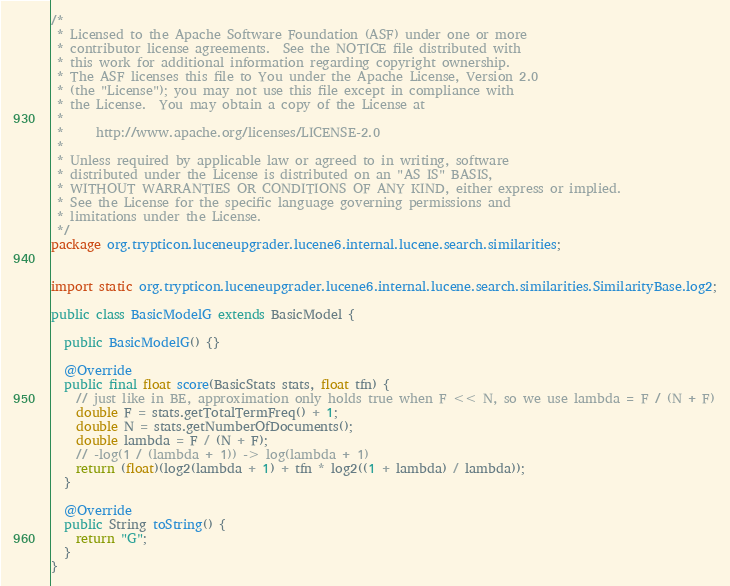<code> <loc_0><loc_0><loc_500><loc_500><_Java_>/*
 * Licensed to the Apache Software Foundation (ASF) under one or more
 * contributor license agreements.  See the NOTICE file distributed with
 * this work for additional information regarding copyright ownership.
 * The ASF licenses this file to You under the Apache License, Version 2.0
 * (the "License"); you may not use this file except in compliance with
 * the License.  You may obtain a copy of the License at
 *
 *     http://www.apache.org/licenses/LICENSE-2.0
 *
 * Unless required by applicable law or agreed to in writing, software
 * distributed under the License is distributed on an "AS IS" BASIS,
 * WITHOUT WARRANTIES OR CONDITIONS OF ANY KIND, either express or implied.
 * See the License for the specific language governing permissions and
 * limitations under the License.
 */
package org.trypticon.luceneupgrader.lucene6.internal.lucene.search.similarities;


import static org.trypticon.luceneupgrader.lucene6.internal.lucene.search.similarities.SimilarityBase.log2;

public class BasicModelG extends BasicModel {
  
  public BasicModelG() {}

  @Override
  public final float score(BasicStats stats, float tfn) {
    // just like in BE, approximation only holds true when F << N, so we use lambda = F / (N + F)
    double F = stats.getTotalTermFreq() + 1;
    double N = stats.getNumberOfDocuments();
    double lambda = F / (N + F);
    // -log(1 / (lambda + 1)) -> log(lambda + 1)
    return (float)(log2(lambda + 1) + tfn * log2((1 + lambda) / lambda));
  }

  @Override
  public String toString() {
    return "G";
  }
}
</code> 